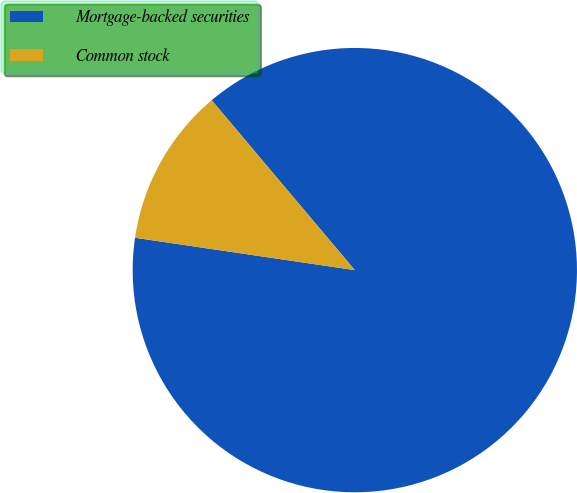Convert chart to OTSL. <chart><loc_0><loc_0><loc_500><loc_500><pie_chart><fcel>Mortgage-backed securities<fcel>Common stock<nl><fcel>88.47%<fcel>11.53%<nl></chart> 